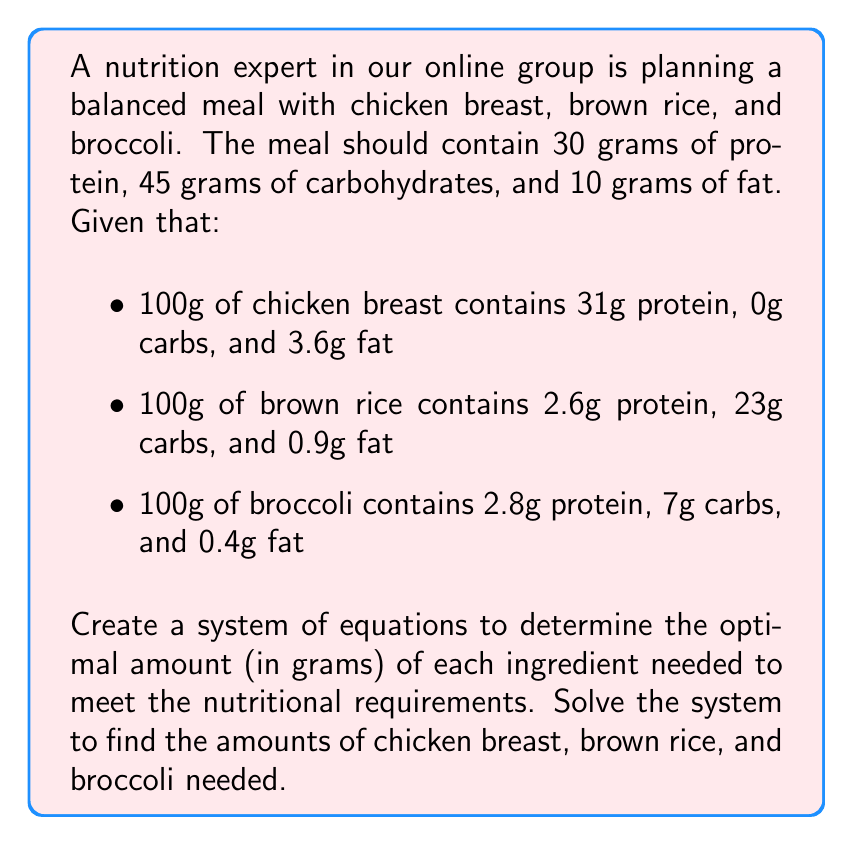Solve this math problem. Let's approach this step-by-step:

1) Let $x$ be the amount of chicken breast in grams
   Let $y$ be the amount of brown rice in grams
   Let $z$ be the amount of broccoli in grams

2) Now, we can set up a system of equations based on the nutritional requirements:

   Protein: $0.31x + 0.026y + 0.028z = 30$
   Carbs: $0y + 0.23y + 0.07z = 45$
   Fat: $0.036x + 0.009y + 0.004z = 10$

3) Let's simplify these equations:

   $31x + 2.6y + 2.8z = 3000$ (multiplied by 100)
   $23y + 7z = 4500$ (multiplied by 100)
   $9x + 2.25y + z = 2500$ (multiplied by 250)

4) We can solve this system using elimination method:

   From equation 2: $y = \frac{4500 - 7z}{23}$

5) Substitute this into equation 1:

   $31x + 2.6(\frac{4500 - 7z}{23}) + 2.8z = 3000$
   $31x + 507.39 - 0.79z + 2.8z = 3000$
   $31x + 2.01z = 2492.61$

6) Now substitute $y$ into equation 3:

   $9x + 2.25(\frac{4500 - 7z}{23}) + z = 2500$
   $9x + 440.22 - 0.68z + z = 2500$
   $9x + 0.32z = 2059.78$

7) Now we have two equations with two unknowns:

   $31x + 2.01z = 2492.61$
   $9x + 0.32z = 2059.78$

8) Multiply the second equation by 31/9:

   $31x + 2.01z = 2492.61$
   $31x + 1.10z = 7094.46$

9) Subtract these equations:

   $0.91z = -4601.85$
   $z = -5056.98$

10) Substitute this value of $z$ back into $9x + 0.32z = 2059.78$:

    $9x + 0.32(-5056.98) = 2059.78$
    $9x = 3678.01$
    $x = 408.67$

11) Finally, calculate $y$:

    $y = \frac{4500 - 7(-5056.98)}{23} = 2200.30$

Therefore, the optimal amounts are:
Chicken breast: 408.67g
Brown rice: 2200.30g
Broccoli: -5056.98g

However, we can't have negative grams of broccoli. This means our system has no feasible solution within the given constraints.
Answer: The system has no feasible solution. It's not possible to create a meal with the exact nutritional requirements using only these three ingredients in non-negative quantities. 